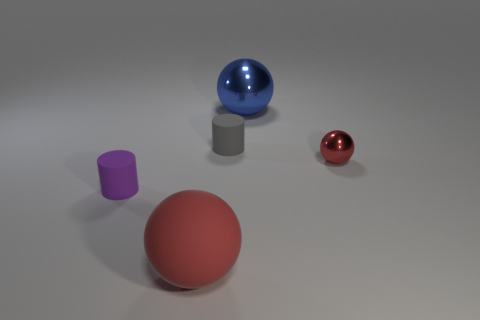Add 1 small gray rubber cylinders. How many objects exist? 6 Subtract all spheres. How many objects are left? 2 Subtract 1 purple cylinders. How many objects are left? 4 Subtract all shiny cylinders. Subtract all matte balls. How many objects are left? 4 Add 4 purple rubber things. How many purple rubber things are left? 5 Add 3 small blue cubes. How many small blue cubes exist? 3 